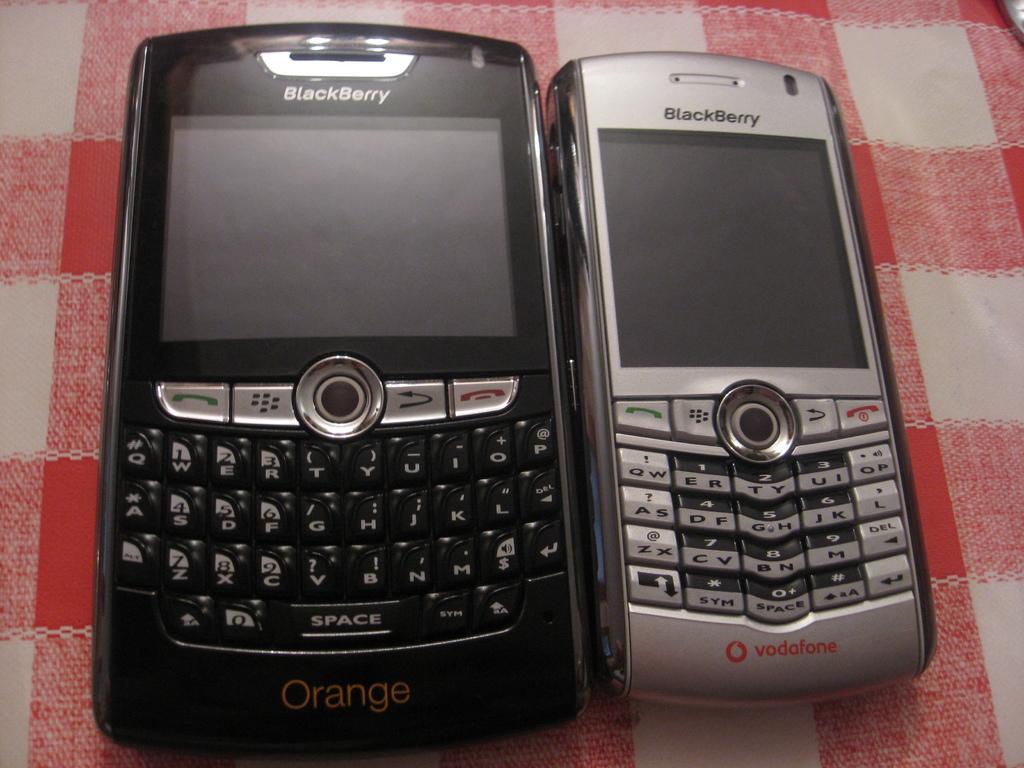Can you describe this image briefly? In this picture we can see two mobiles of black and silver colors and these two are placed on a cloth. 